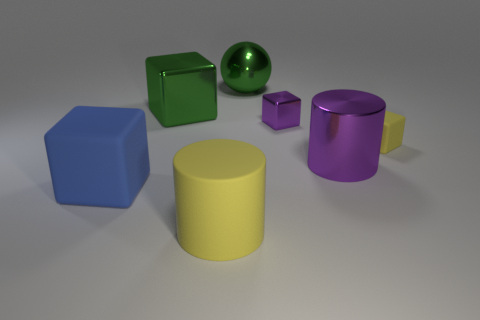Subtract 1 blocks. How many blocks are left? 3 Add 3 tiny metal cubes. How many objects exist? 10 Subtract all spheres. How many objects are left? 6 Add 5 large matte objects. How many large matte objects are left? 7 Add 7 tiny purple spheres. How many tiny purple spheres exist? 7 Subtract 0 red cylinders. How many objects are left? 7 Subtract all purple blocks. Subtract all matte cylinders. How many objects are left? 5 